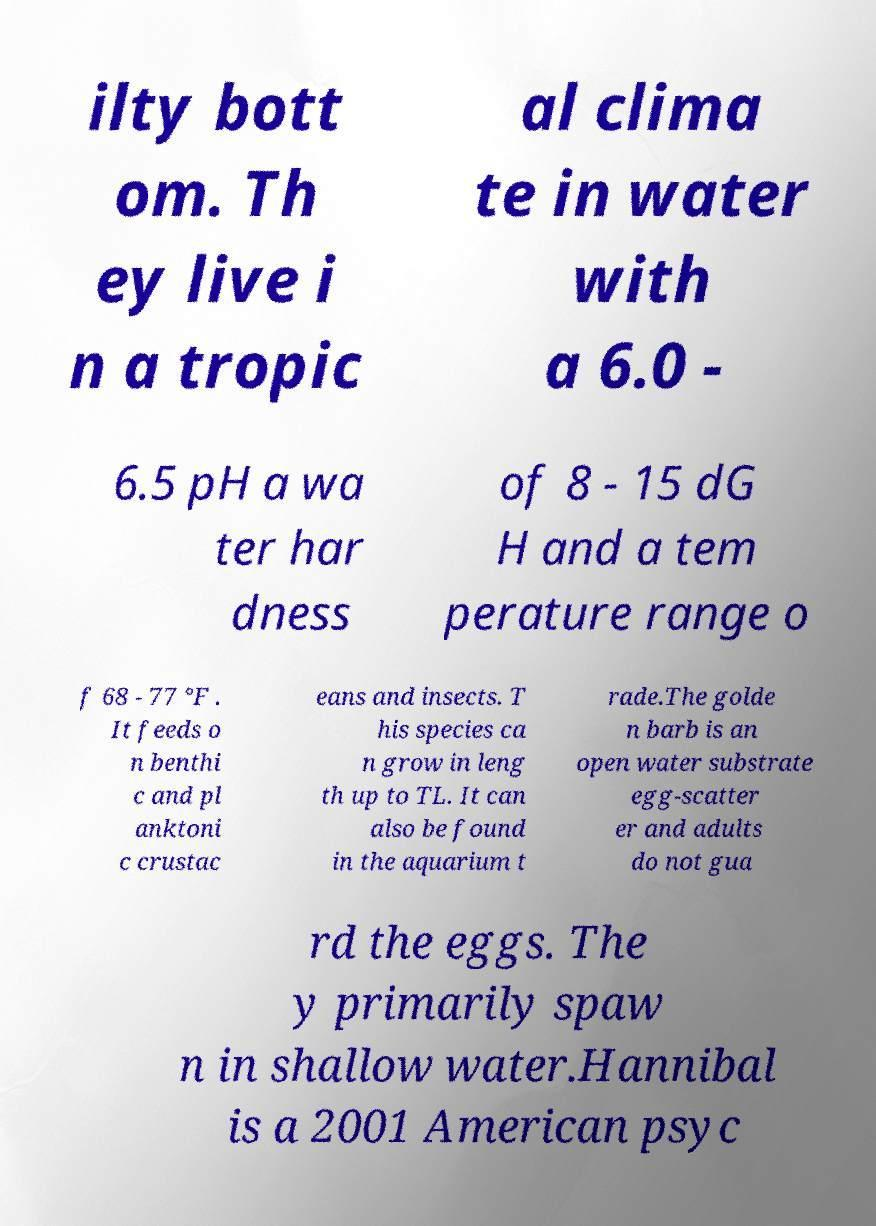Could you extract and type out the text from this image? ilty bott om. Th ey live i n a tropic al clima te in water with a 6.0 - 6.5 pH a wa ter har dness of 8 - 15 dG H and a tem perature range o f 68 - 77 °F . It feeds o n benthi c and pl anktoni c crustac eans and insects. T his species ca n grow in leng th up to TL. It can also be found in the aquarium t rade.The golde n barb is an open water substrate egg-scatter er and adults do not gua rd the eggs. The y primarily spaw n in shallow water.Hannibal is a 2001 American psyc 